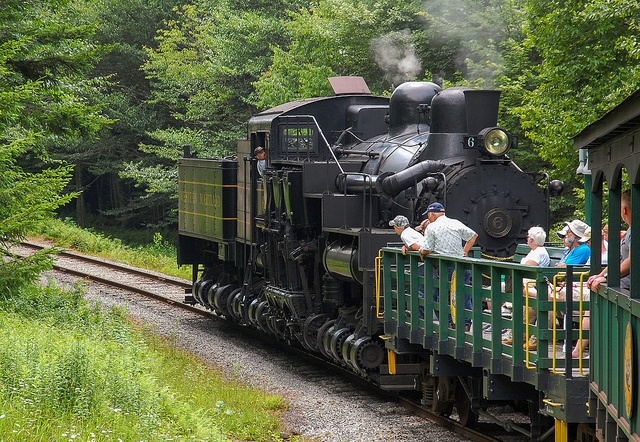Describe the objects in this image and their specific colors. I can see train in darkgreen, black, and gray tones, people in darkgreen, lightgray, darkgray, lightblue, and black tones, people in darkgreen, black, gray, brown, and maroon tones, people in darkgreen, lightblue, lightgray, darkgray, and brown tones, and people in darkgreen, white, darkgray, and lightpink tones in this image. 